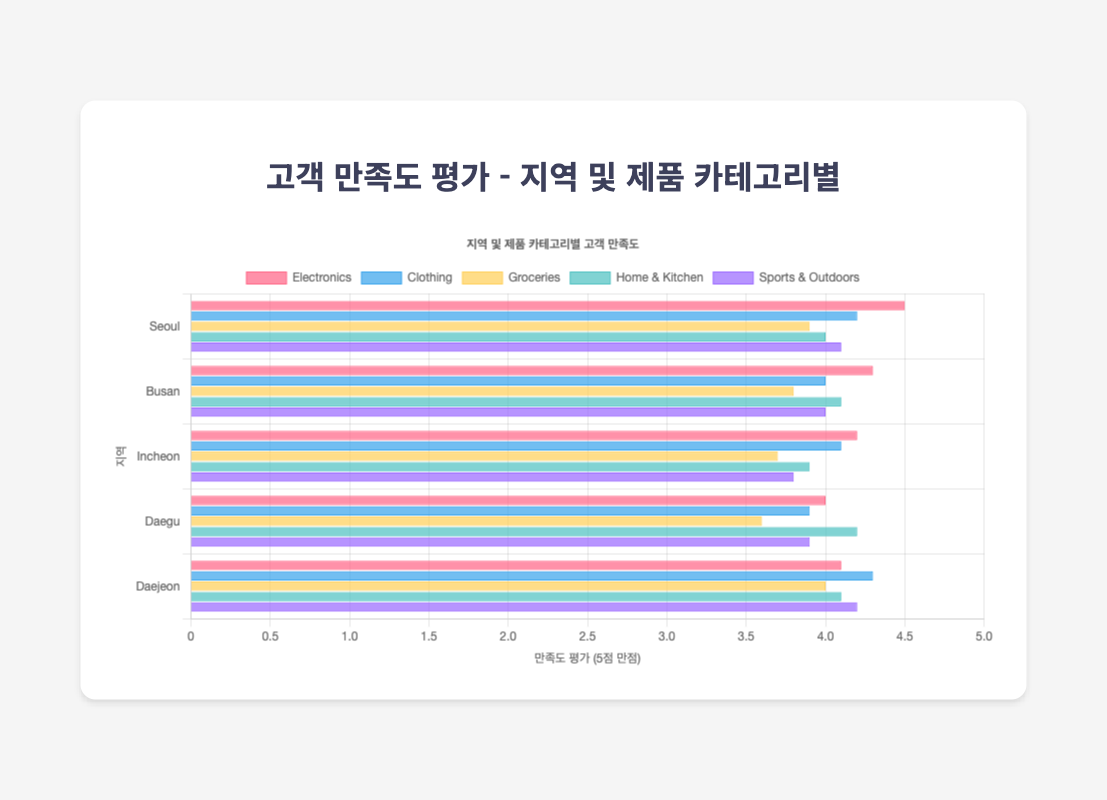How does customer satisfaction for Electronics compare between Seoul and Busan? The bar for Electronics in Seoul is higher than the bar for Electronics in Busan. Specifically, the rating for Electronics in Seoul is 4.5 while in Busan it is 4.3.
Answer: Seoul's Electronics satisfaction is higher Which Store Location has the highest customer satisfaction for Clothing? To determine this, look for the highest bar in the Clothing category. Daejeon has the highest satisfaction for Clothing with a rating of 4.3.
Answer: Daejeon What is the average customer satisfaction rating for Groceries in all store locations combined? Add the Groceries ratings for all store locations and divide by the number of locations. The sum is 3.9+3.8+3.7+3.6+4.0 = 19.0. Dividing by 5 locations: 19.0/5 = 3.8.
Answer: 3.8 Which Product Category has the most consistent customer satisfaction ratings across all store locations? Look for the category with the smallest range between its highest and lowest satisfaction ratings. For instance, Sports & Outdoors ratings range from 3.8 to 4.2, a difference of 0.4, which is the smallest among all categories.
Answer: Sports & Outdoors Compare the customer satisfaction ratings for Home & Kitchen between Daegu and Daejeon. Which one is higher and by how much? The rating for Home & Kitchen in Daegu is 4.2, and in Daejeon, it is 4.1. Therefore, Daegu's rating is higher by 0.1 points.
Answer: Daegu's rating is higher by 0.1 What is the lowest customer satisfaction rating across all categories and store locations? Identify the lowest bar across all categories and locations. The lowest rating is for Groceries in Daegu, which is 3.6.
Answer: Groceries in Daegu In which Store Location do Electronics and Clothing both have higher than average satisfaction ratings? The average rating for Electronics is (4.5+4.3+4.2+4.0+4.1)/5 = 4.22 and for Clothing is (4.2+4.0+4.1+3.9+4.3)/5 = 4.10. Seoul (Electronics 4.5, Clothing 4.2) and Daejeon (Electronics 4.1, Clothing 4.3) both exceed these averages.
Answer: Seoul and Daejeon Which location has the greatest difference in customer satisfaction ratings between two product categories, and what are those categories? Examine all locations for the greatest absolute difference between the highest and lowest ratings in any two categories. Incheon has the greatest difference between Electronics (4.2) and Groceries (3.7), which is 0.5.
Answer: Incheon, between Electronics and Groceries 